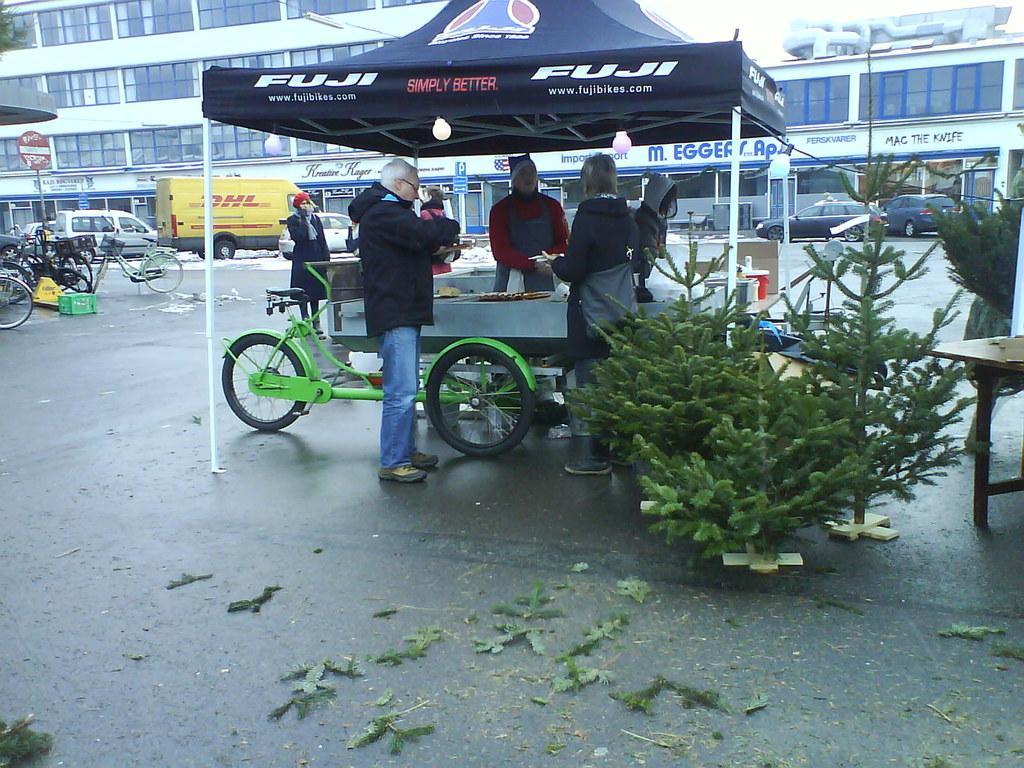In one or two sentences, can you explain what this image depicts? In the image there is a tent with rods and lights. Below the text there is a cart with table and few items on it. There are few people in the image. There are plants with leaves. On the road there are leaves. In the background there are vehicles and poles with sign board. There is a building with glass windows, walls and pillars. On the right side of the image there is a table. 